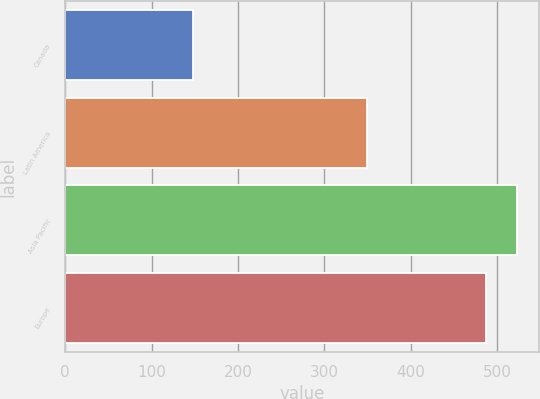<chart> <loc_0><loc_0><loc_500><loc_500><bar_chart><fcel>Canada<fcel>Latin America<fcel>Asia Pacific<fcel>Europe<nl><fcel>148.1<fcel>349.5<fcel>522.87<fcel>486.7<nl></chart> 